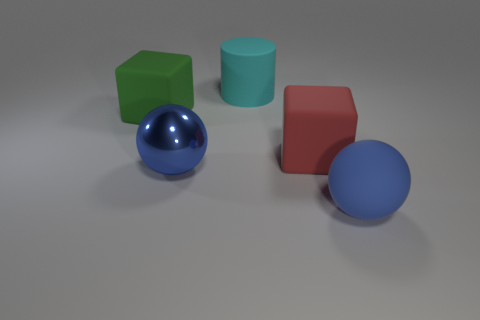Add 5 brown matte objects. How many objects exist? 10 Subtract all cylinders. How many objects are left? 4 Subtract 0 brown cubes. How many objects are left? 5 Subtract all metallic objects. Subtract all green rubber cubes. How many objects are left? 3 Add 5 red blocks. How many red blocks are left? 6 Add 4 big brown matte balls. How many big brown matte balls exist? 4 